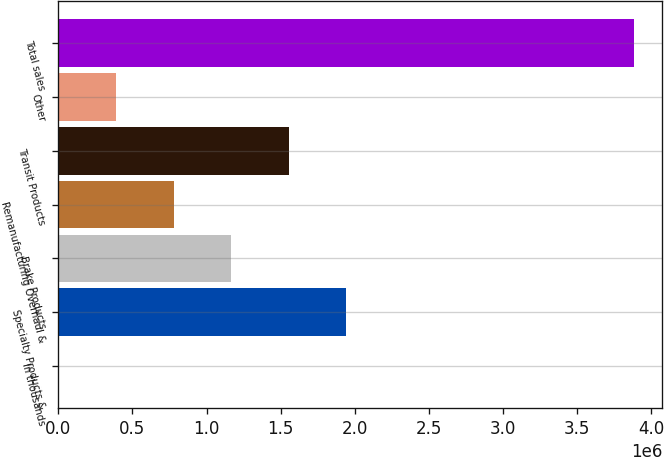<chart> <loc_0><loc_0><loc_500><loc_500><bar_chart><fcel>In thousands<fcel>Specialty Products &<fcel>Brake Products<fcel>Remanufacturing Overhaul &<fcel>Transit Products<fcel>Other<fcel>Total sales<nl><fcel>2017<fcel>1.94189e+06<fcel>1.16594e+06<fcel>777965<fcel>1.55391e+06<fcel>389991<fcel>3.88176e+06<nl></chart> 